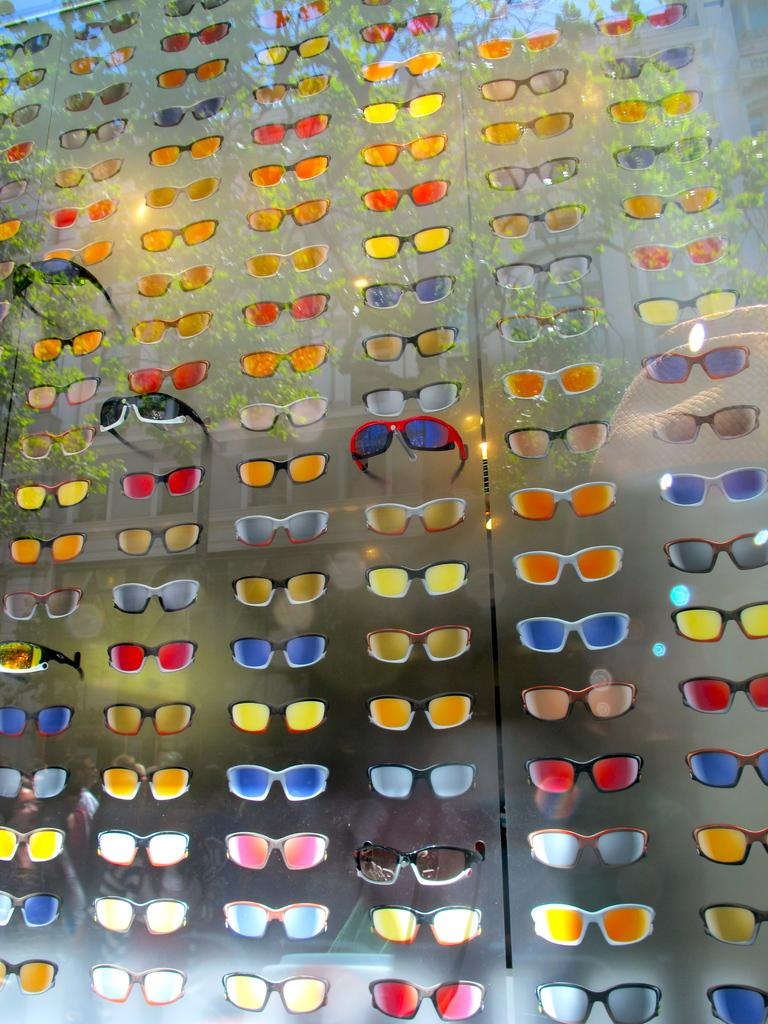What type of wall is visible in the image? There is a glass wall in the image. What is attached to the glass wall? Many goggles are attached to the glass wall. What can be observed about the goggles? The goggles have different colors. How much money can be seen in the image? There is no money visible in the image; it features a glass wall with goggles. What type of vegetable is growing on the glass wall in the image? There are no vegetables present in the image, and the glass wall is not a growing environment for plants. 